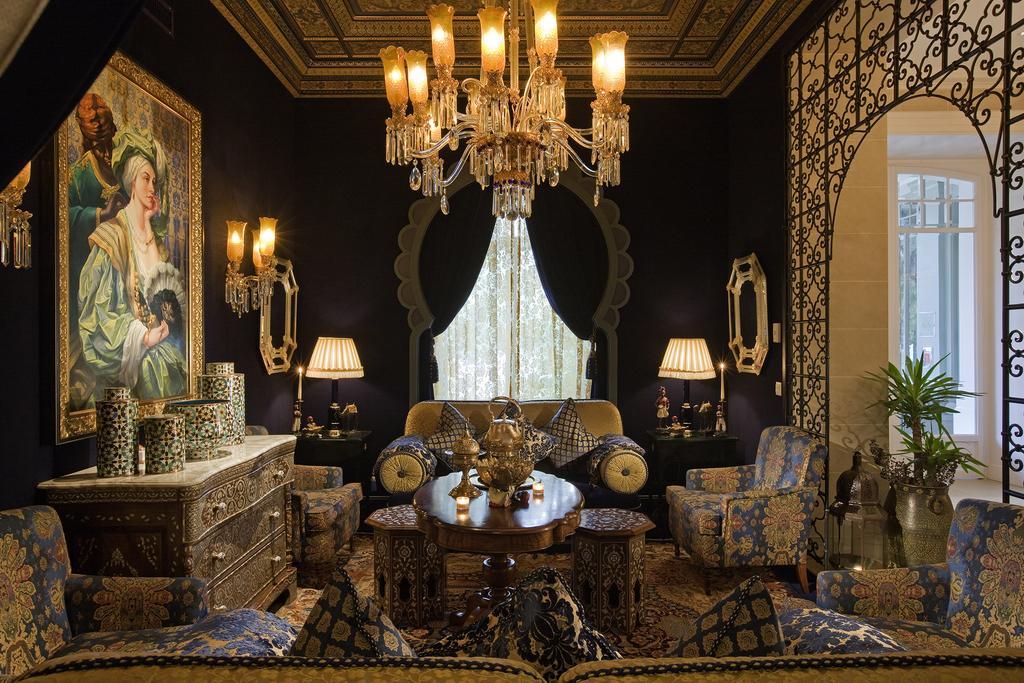How would you summarize this image in a sentence or two? This picture is taken in the room, There are some sofas there is a table on that table there are some objects kept and in the left side there is a wooden box and there are some objects, There is a poster of woman, In the top there is a object hanging on the roof there are some lights in yellow color, In the background there is a black color curtain and in the right side there is a fence which is in black color and there is a green color plant. 